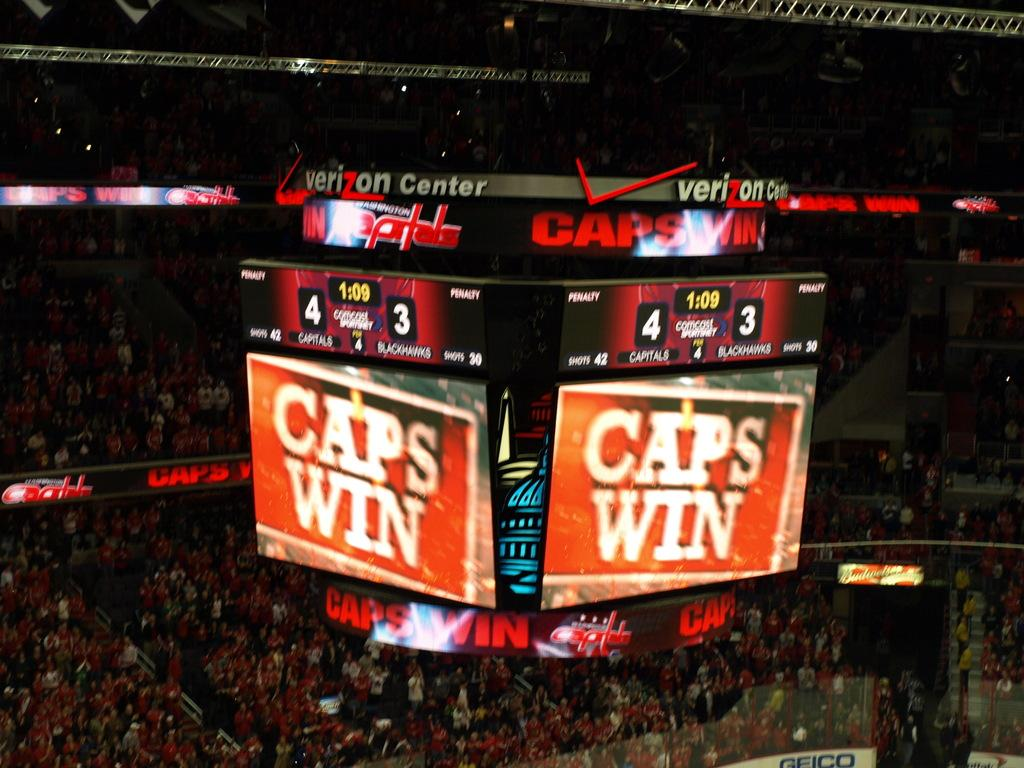<image>
Present a compact description of the photo's key features. A Jumbotron screen that says Caps Win and Verizon on top. 